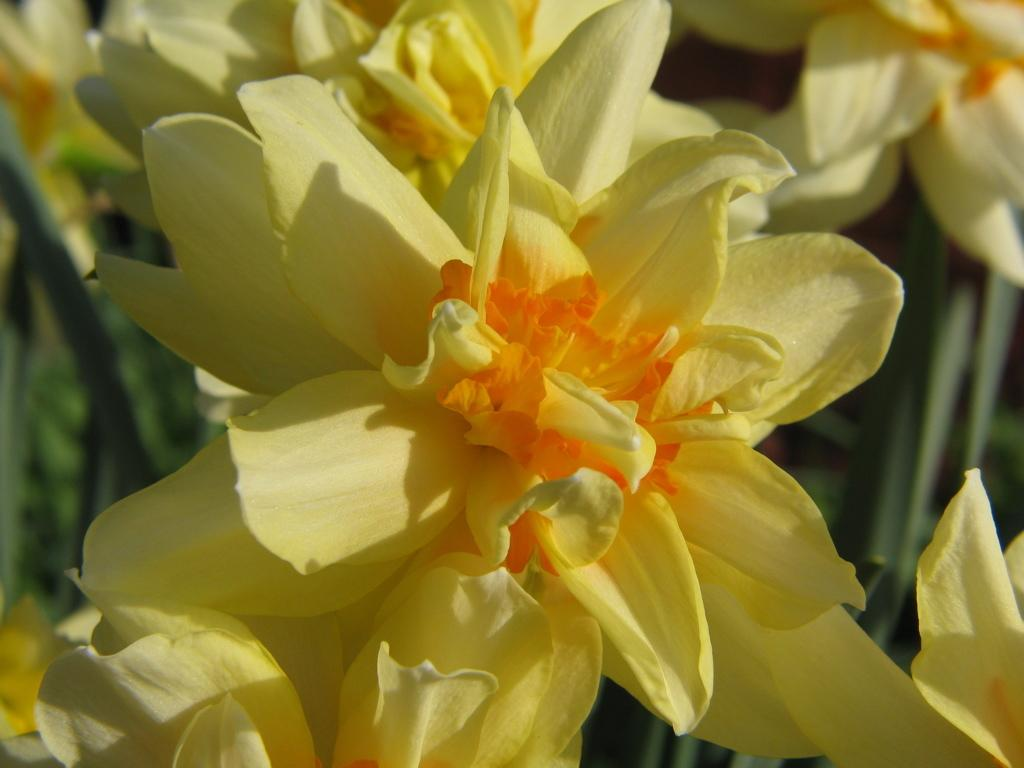What type of objects are present in the image? There are flowers in the image. What color are the flowers? The flowers are in yellow color. Is there a book lying next to the flowers in the image? There is no mention of a book in the provided facts, so we cannot determine if there is a book in the image. 